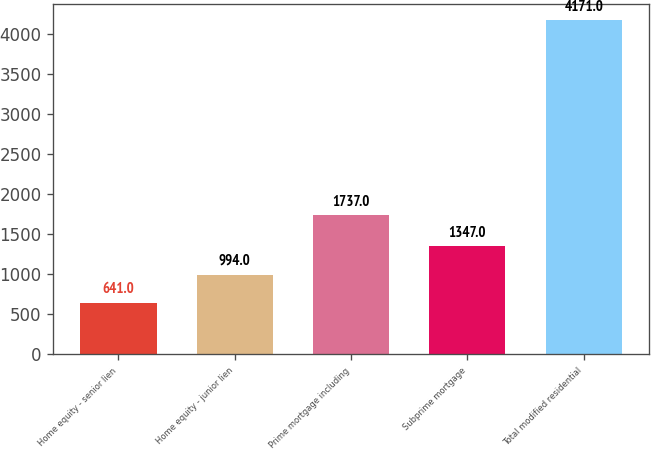Convert chart. <chart><loc_0><loc_0><loc_500><loc_500><bar_chart><fcel>Home equity - senior lien<fcel>Home equity - junior lien<fcel>Prime mortgage including<fcel>Subprime mortgage<fcel>Total modified residential<nl><fcel>641<fcel>994<fcel>1737<fcel>1347<fcel>4171<nl></chart> 